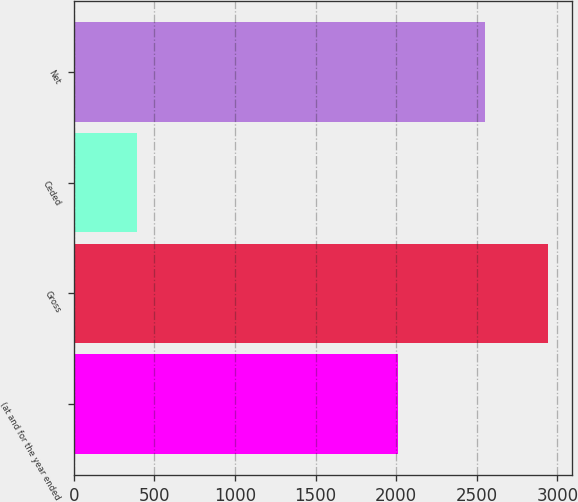Convert chart. <chart><loc_0><loc_0><loc_500><loc_500><bar_chart><fcel>(at and for the year ended<fcel>Gross<fcel>Ceded<fcel>Net<nl><fcel>2011<fcel>2941<fcel>393<fcel>2548<nl></chart> 